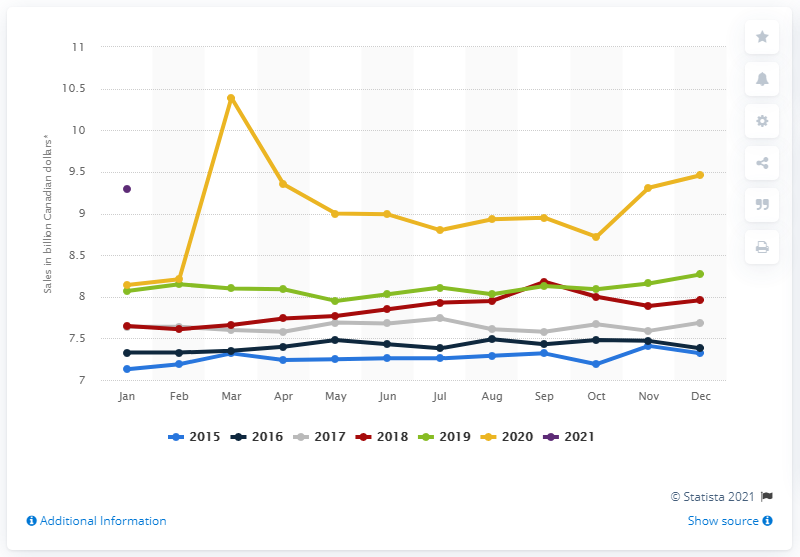Can you identify any trends in grocery sales over the years presented? Upon reviewing the chart, it appears that there is a mild upward trend in grocery sales over the years from 2015 to 2021. Additionally, there are seasonal variations with slight peaks around the December holidays each year, which is consistent with increased seasonal spending. 